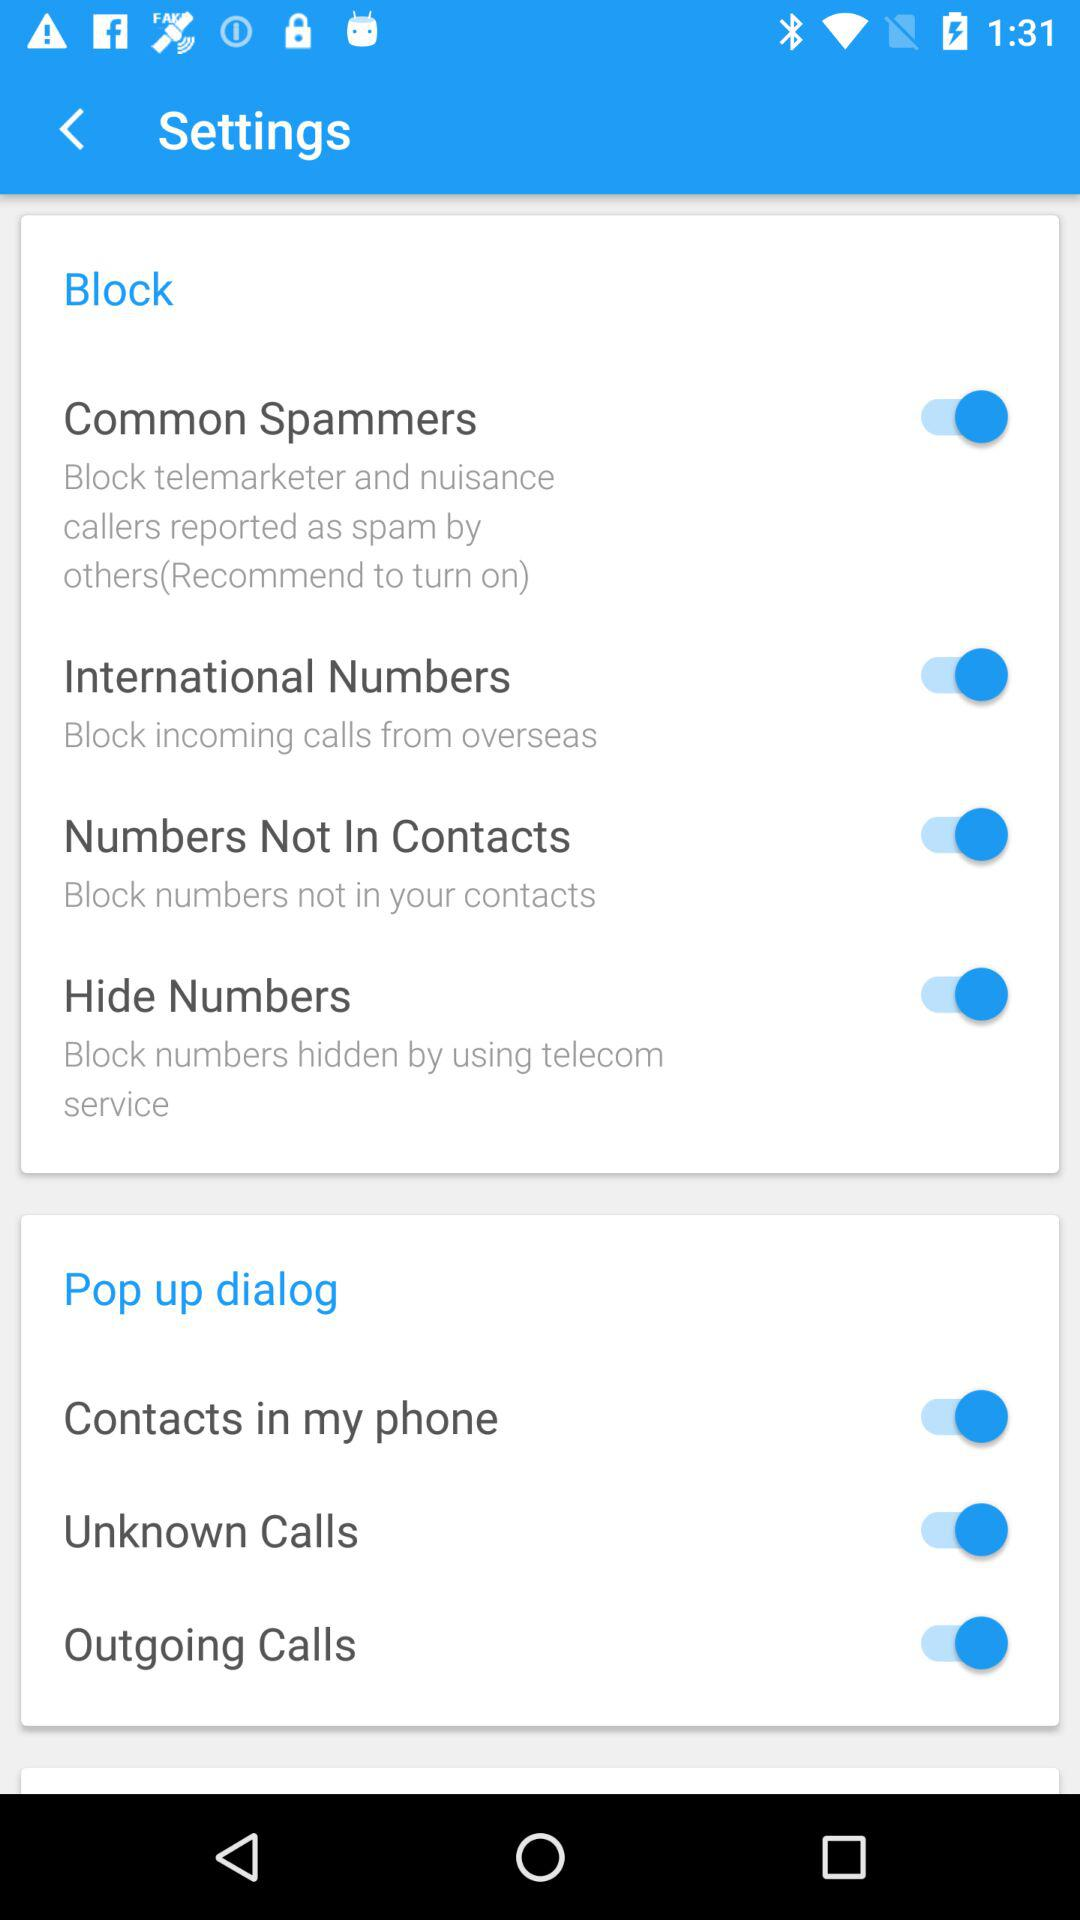What is the status of the "Common Spammers"? The status of the "Common Spammers" is "on". 